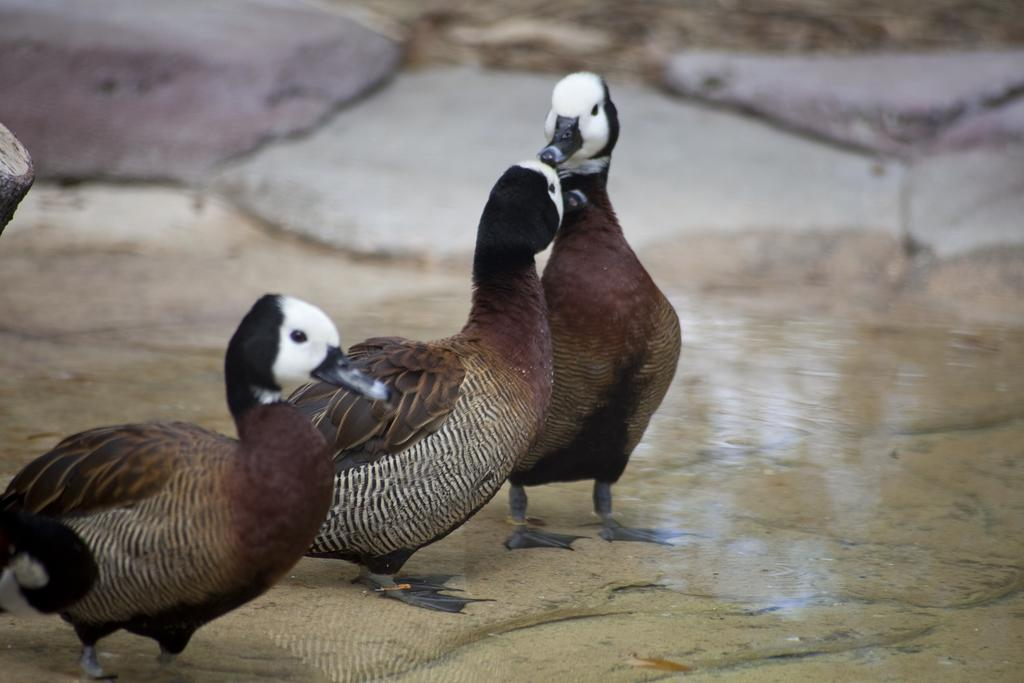What type of animals can be seen in the image? Birds can be seen in the image. What is the primary element in which the birds are situated? The birds are situated in water. What other objects are present in the image? There are rocks in the image. What word is being spelled out by the birds in the image? There is no indication in the image that the birds are spelling out any word. What type of waste can be seen floating in the water in the image? There is no waste visible in the image; it features birds in the water. 